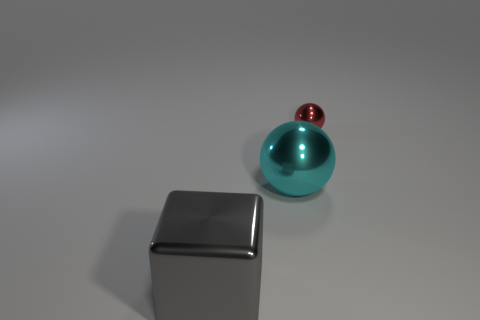The cyan object has what size?
Keep it short and to the point. Large. How big is the metal thing that is both to the right of the big gray metal thing and left of the small ball?
Provide a short and direct response. Large. The metal object in front of the cyan thing has what shape?
Give a very brief answer. Cube. Do the big ball and the ball that is behind the big cyan ball have the same material?
Ensure brevity in your answer.  Yes. Is the shape of the cyan metallic thing the same as the gray metallic thing?
Keep it short and to the point. No. There is another object that is the same shape as the small object; what is its material?
Provide a short and direct response. Metal. What color is the object that is behind the big gray cube and to the left of the tiny sphere?
Your answer should be compact. Cyan. What color is the metal cube?
Provide a short and direct response. Gray. Are there any blue metallic things of the same shape as the gray object?
Offer a very short reply. No. There is a ball that is in front of the tiny metallic object; how big is it?
Offer a very short reply. Large. 